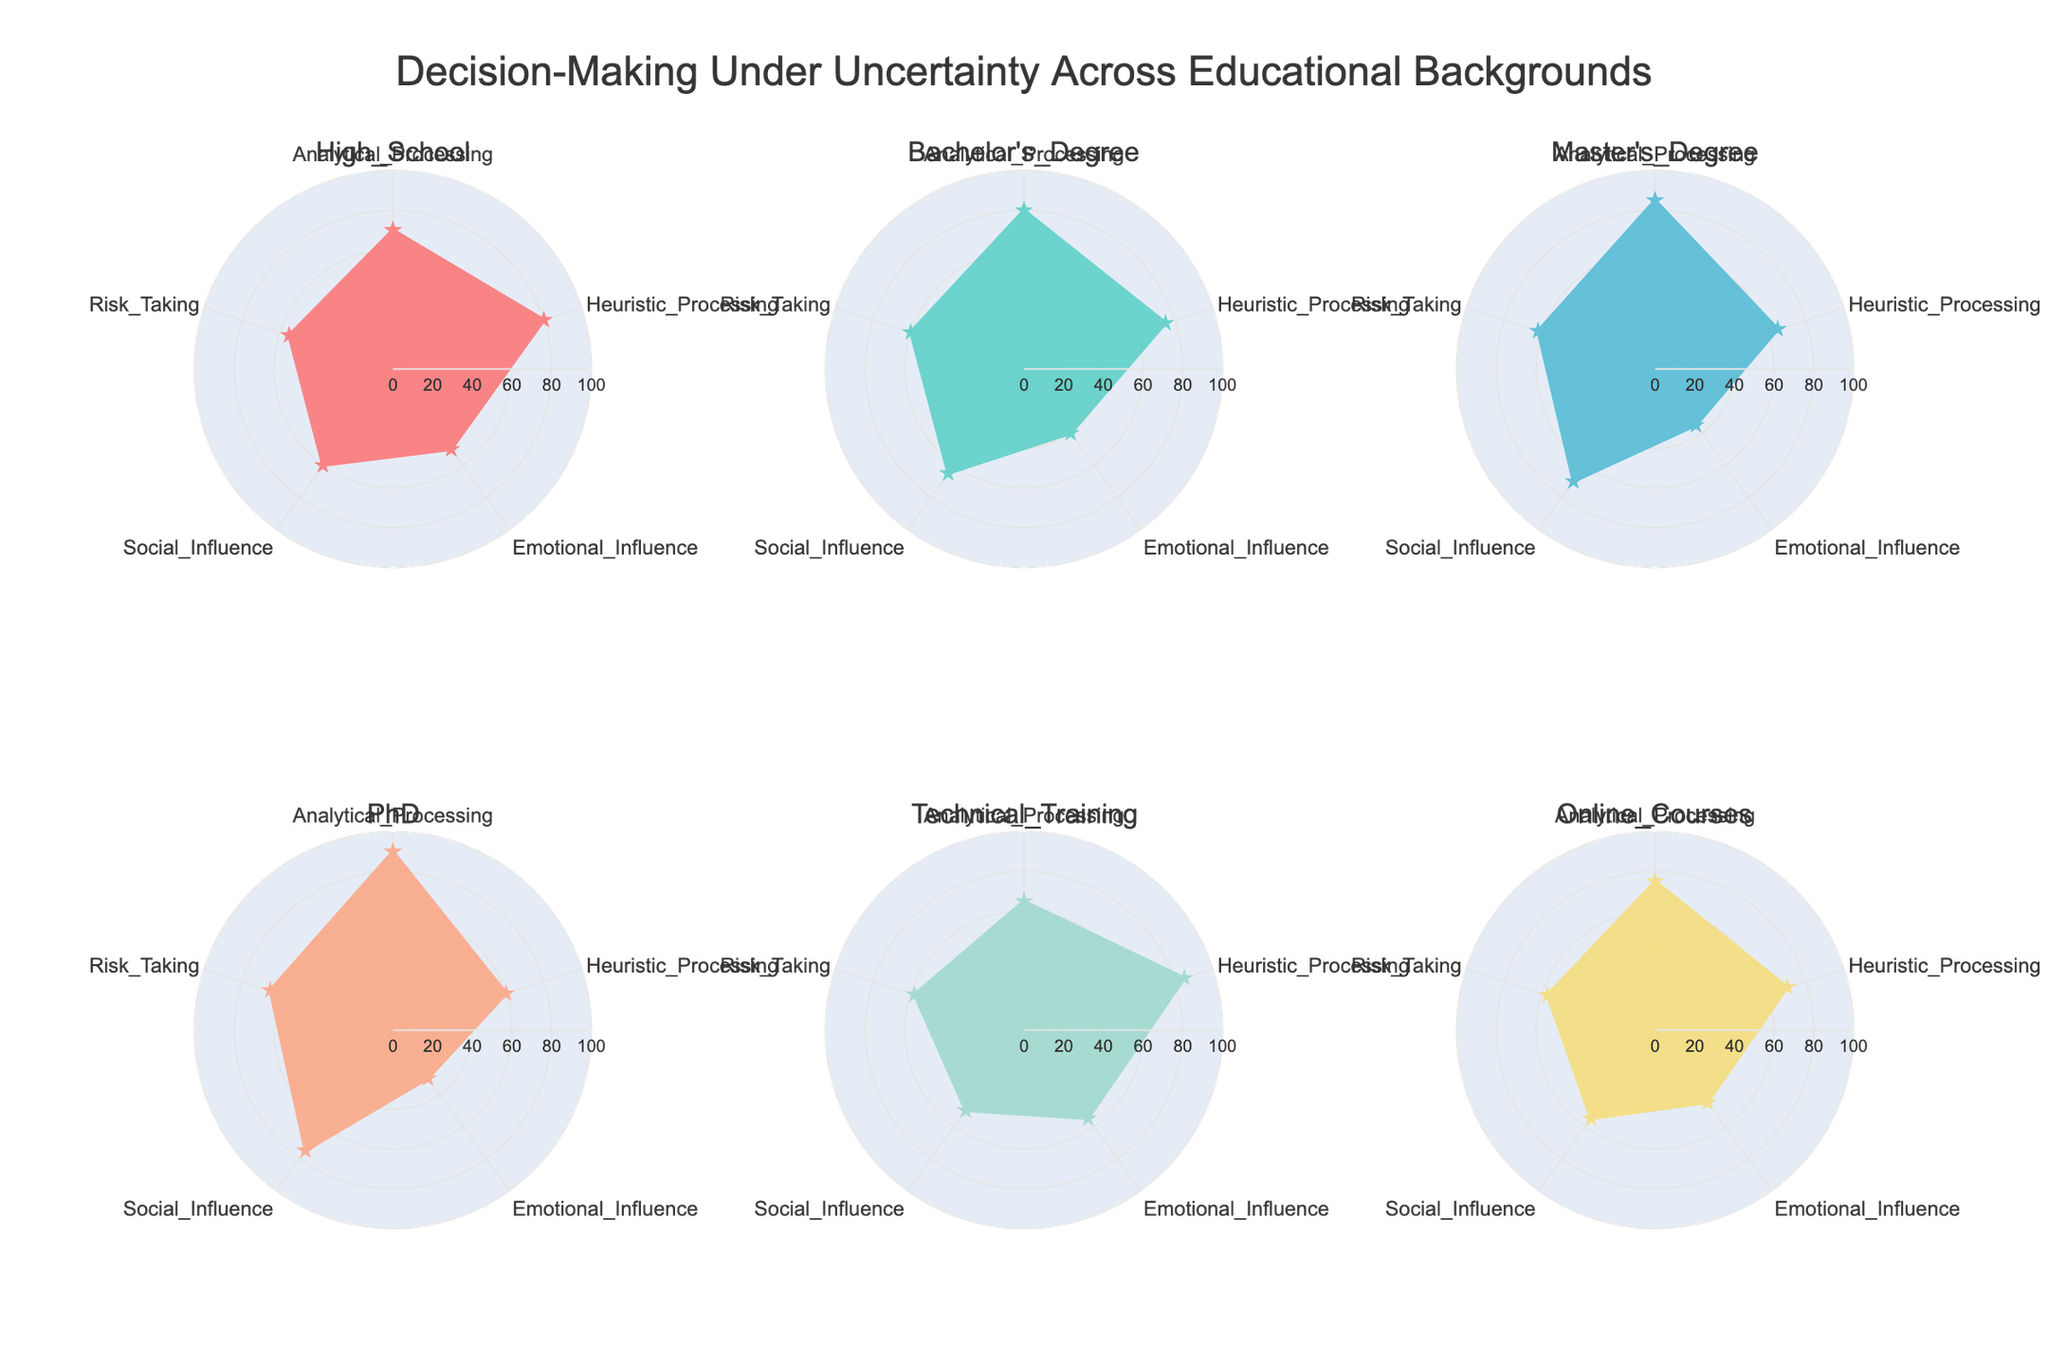What is the title of the figure? The title is prominently displayed at the top of the figure, and it reads "Decision-Making Under Uncertainty Across Educational Backgrounds".
Answer: Decision-Making Under Uncertainty Across Educational Backgrounds Which educational background has the highest Emotional Influence score? In the radar chart, the 'Emotional Influence' axis is one of the five axes, and by inspecting the data points on this axis, the Technical Training educational background stands out with the highest value of 55.
Answer: Technical Training What is the average Heuristic Processing score across all educational backgrounds? To find the average, add the Heuristic Processing scores for each educational background and then divide by the number of backgrounds. The values are 80, 75, 65, 60, 85, and 70. Sum them up to get 435, then divide by 6 to get the average.
Answer: 72.5 Which two educational backgrounds have the closest scores in Social Influence? Inspecting the 'Social Influence' axis, Technical Training and Online Courses have the closest scores, with values of 50 and 55, respectively.
Answer: Technical Training and Online Courses What is the difference in Analytical Processing scores between Master's Degree and High School? Locate the Analytical Processing scores for Master's Degree (85) and High School (70). Subtract the High School score from the Master's Degree score: 85 - 70 = 15.
Answer: 15 Which educational background exhibits the highest Risk-Taking score? Inspection of the 'Risk-Taking' axis shows that the PhD background has the highest score of 65.
Answer: PhD How many educational backgrounds are included in the figure? The figure contains multiple subplots representing each educational background. By counting the subplot titles, we find there are six educational backgrounds displayed.
Answer: 6 Which educational background has the lowest score in Emotional Influence, and what is that score? Inspect the Emotional Influence axis for the lowest value. The PhD background shows the lowest score of 30.
Answer: PhD, 30 Compare the Heuristic Processing scores of Bachelor's Degree and PhD. Which one is higher and by how much? Look at the Heuristic Processing scores for both: Bachelor's Degree is 75, PhD is 60. The difference is 75 - 60 = 15, with Bachelor's Degree being higher.
Answer: Bachelor's Degree by 15 What is the sum of the Social Influence scores of all educational backgrounds? Sum the Social Influence scores: 60 (High School) + 65 (Bachelor's Degree) + 70 (Master's Degree) + 75 (PhD) + 50 (Technical Training) + 55 (Online Courses) = 375.
Answer: 375 